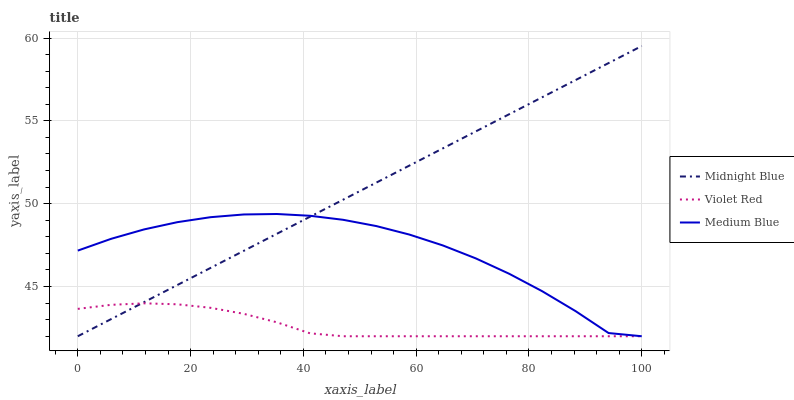Does Violet Red have the minimum area under the curve?
Answer yes or no. Yes. Does Midnight Blue have the maximum area under the curve?
Answer yes or no. Yes. Does Medium Blue have the minimum area under the curve?
Answer yes or no. No. Does Medium Blue have the maximum area under the curve?
Answer yes or no. No. Is Midnight Blue the smoothest?
Answer yes or no. Yes. Is Medium Blue the roughest?
Answer yes or no. Yes. Is Medium Blue the smoothest?
Answer yes or no. No. Is Midnight Blue the roughest?
Answer yes or no. No. Does Violet Red have the lowest value?
Answer yes or no. Yes. Does Midnight Blue have the highest value?
Answer yes or no. Yes. Does Medium Blue have the highest value?
Answer yes or no. No. Does Violet Red intersect Midnight Blue?
Answer yes or no. Yes. Is Violet Red less than Midnight Blue?
Answer yes or no. No. Is Violet Red greater than Midnight Blue?
Answer yes or no. No. 